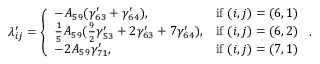Convert formula to latex. <formula><loc_0><loc_0><loc_500><loc_500>\lambda _ { i j } ^ { \prime } = \left \{ \begin{array} { l l } { - A _ { 5 9 } ( \gamma _ { 6 3 } ^ { \prime } + \gamma _ { 6 4 } ^ { \prime } ) , } & { i f ( i , j ) = ( 6 , 1 ) } \\ { \frac { 1 } { 5 } A _ { 5 9 } ( \frac { 9 } { 2 } \gamma _ { 5 3 } ^ { \prime } + 2 \gamma _ { 6 3 } ^ { \prime } + 7 \gamma _ { 6 4 } ^ { \prime } ) , } & { i f ( i , j ) = ( 6 , 2 ) } \\ { - 2 A _ { 5 9 } \gamma _ { 7 1 } ^ { \prime } , } & { i f ( i , j ) = ( 7 , 1 ) } \end{array} .</formula> 